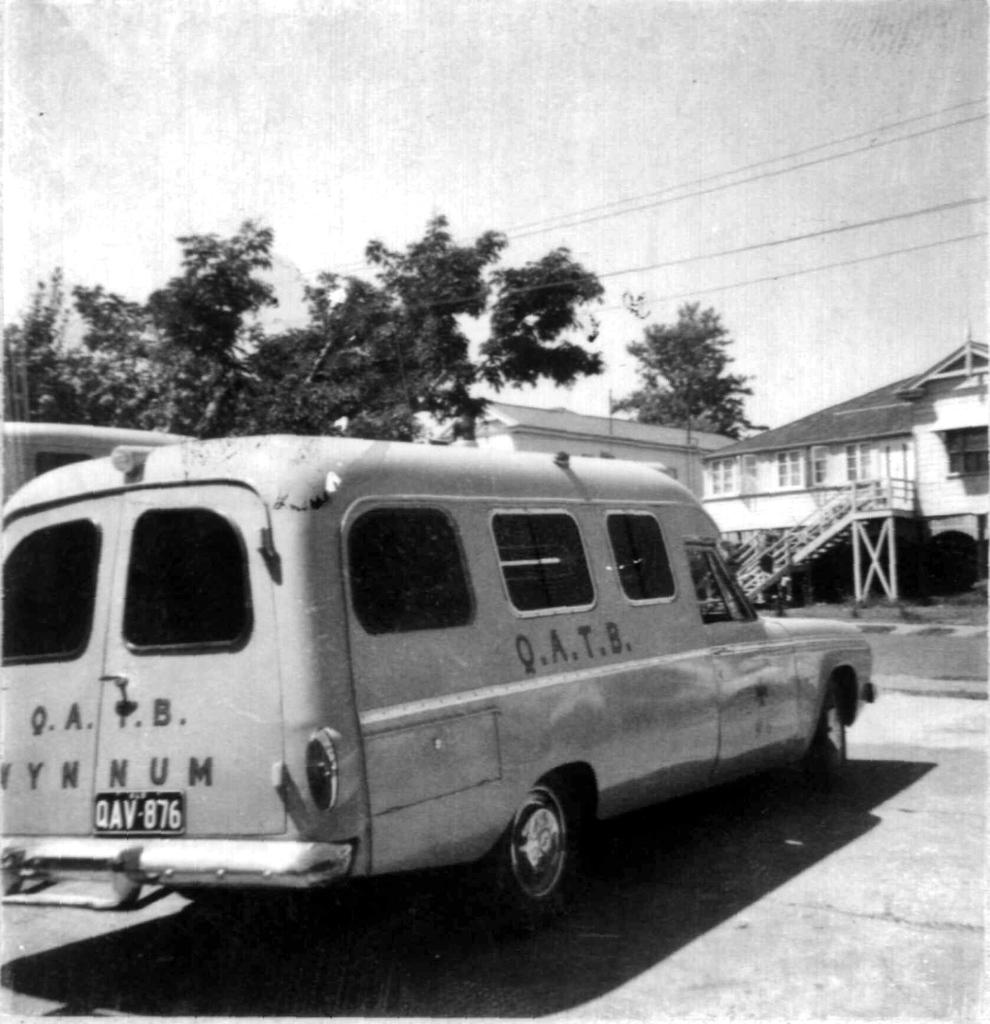What is the color scheme of the image? The image is black and white. What can be seen on the road in the image? There are vehicles on the road in the image. What type of structures are present in the image? There are houses in the image. What type of vegetation is visible in the image? There are trees in the image. What is visible in the background of the image? The sky is visible in the background of the image. What shape is the map on the table in the image? There is no map present in the image; it is a black and white image featuring vehicles, houses, trees, and the sky. 